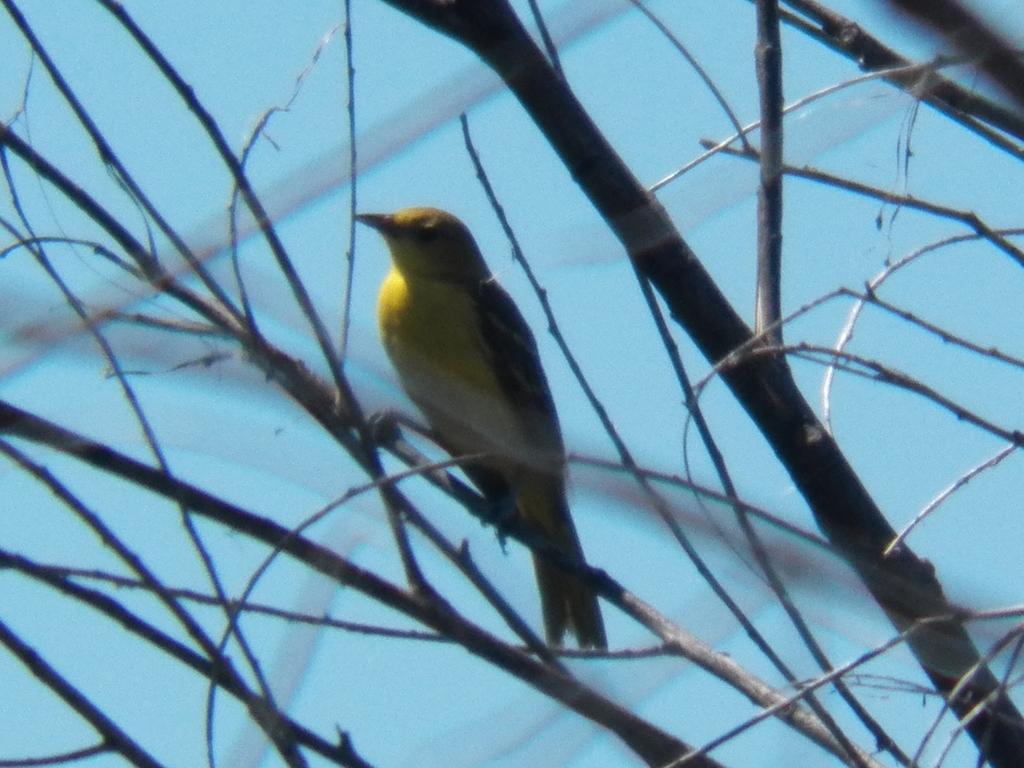Could you give a brief overview of what you see in this image? In this image there is a bird sitting on the branches of a tree. 